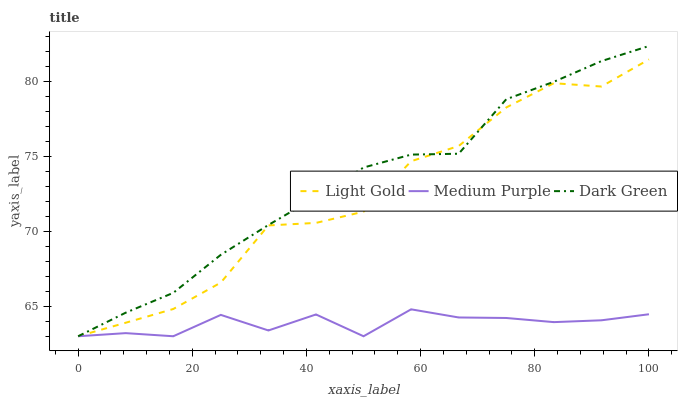Does Light Gold have the minimum area under the curve?
Answer yes or no. No. Does Light Gold have the maximum area under the curve?
Answer yes or no. No. Is Light Gold the smoothest?
Answer yes or no. No. Is Dark Green the roughest?
Answer yes or no. No. Does Light Gold have the highest value?
Answer yes or no. No. 